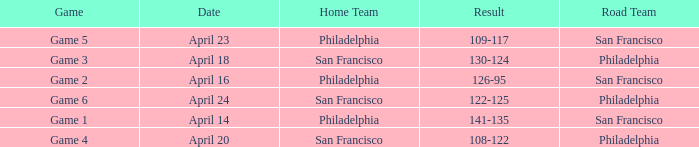What was the result of the game played on April 16 with Philadelphia as home team? 126-95. 